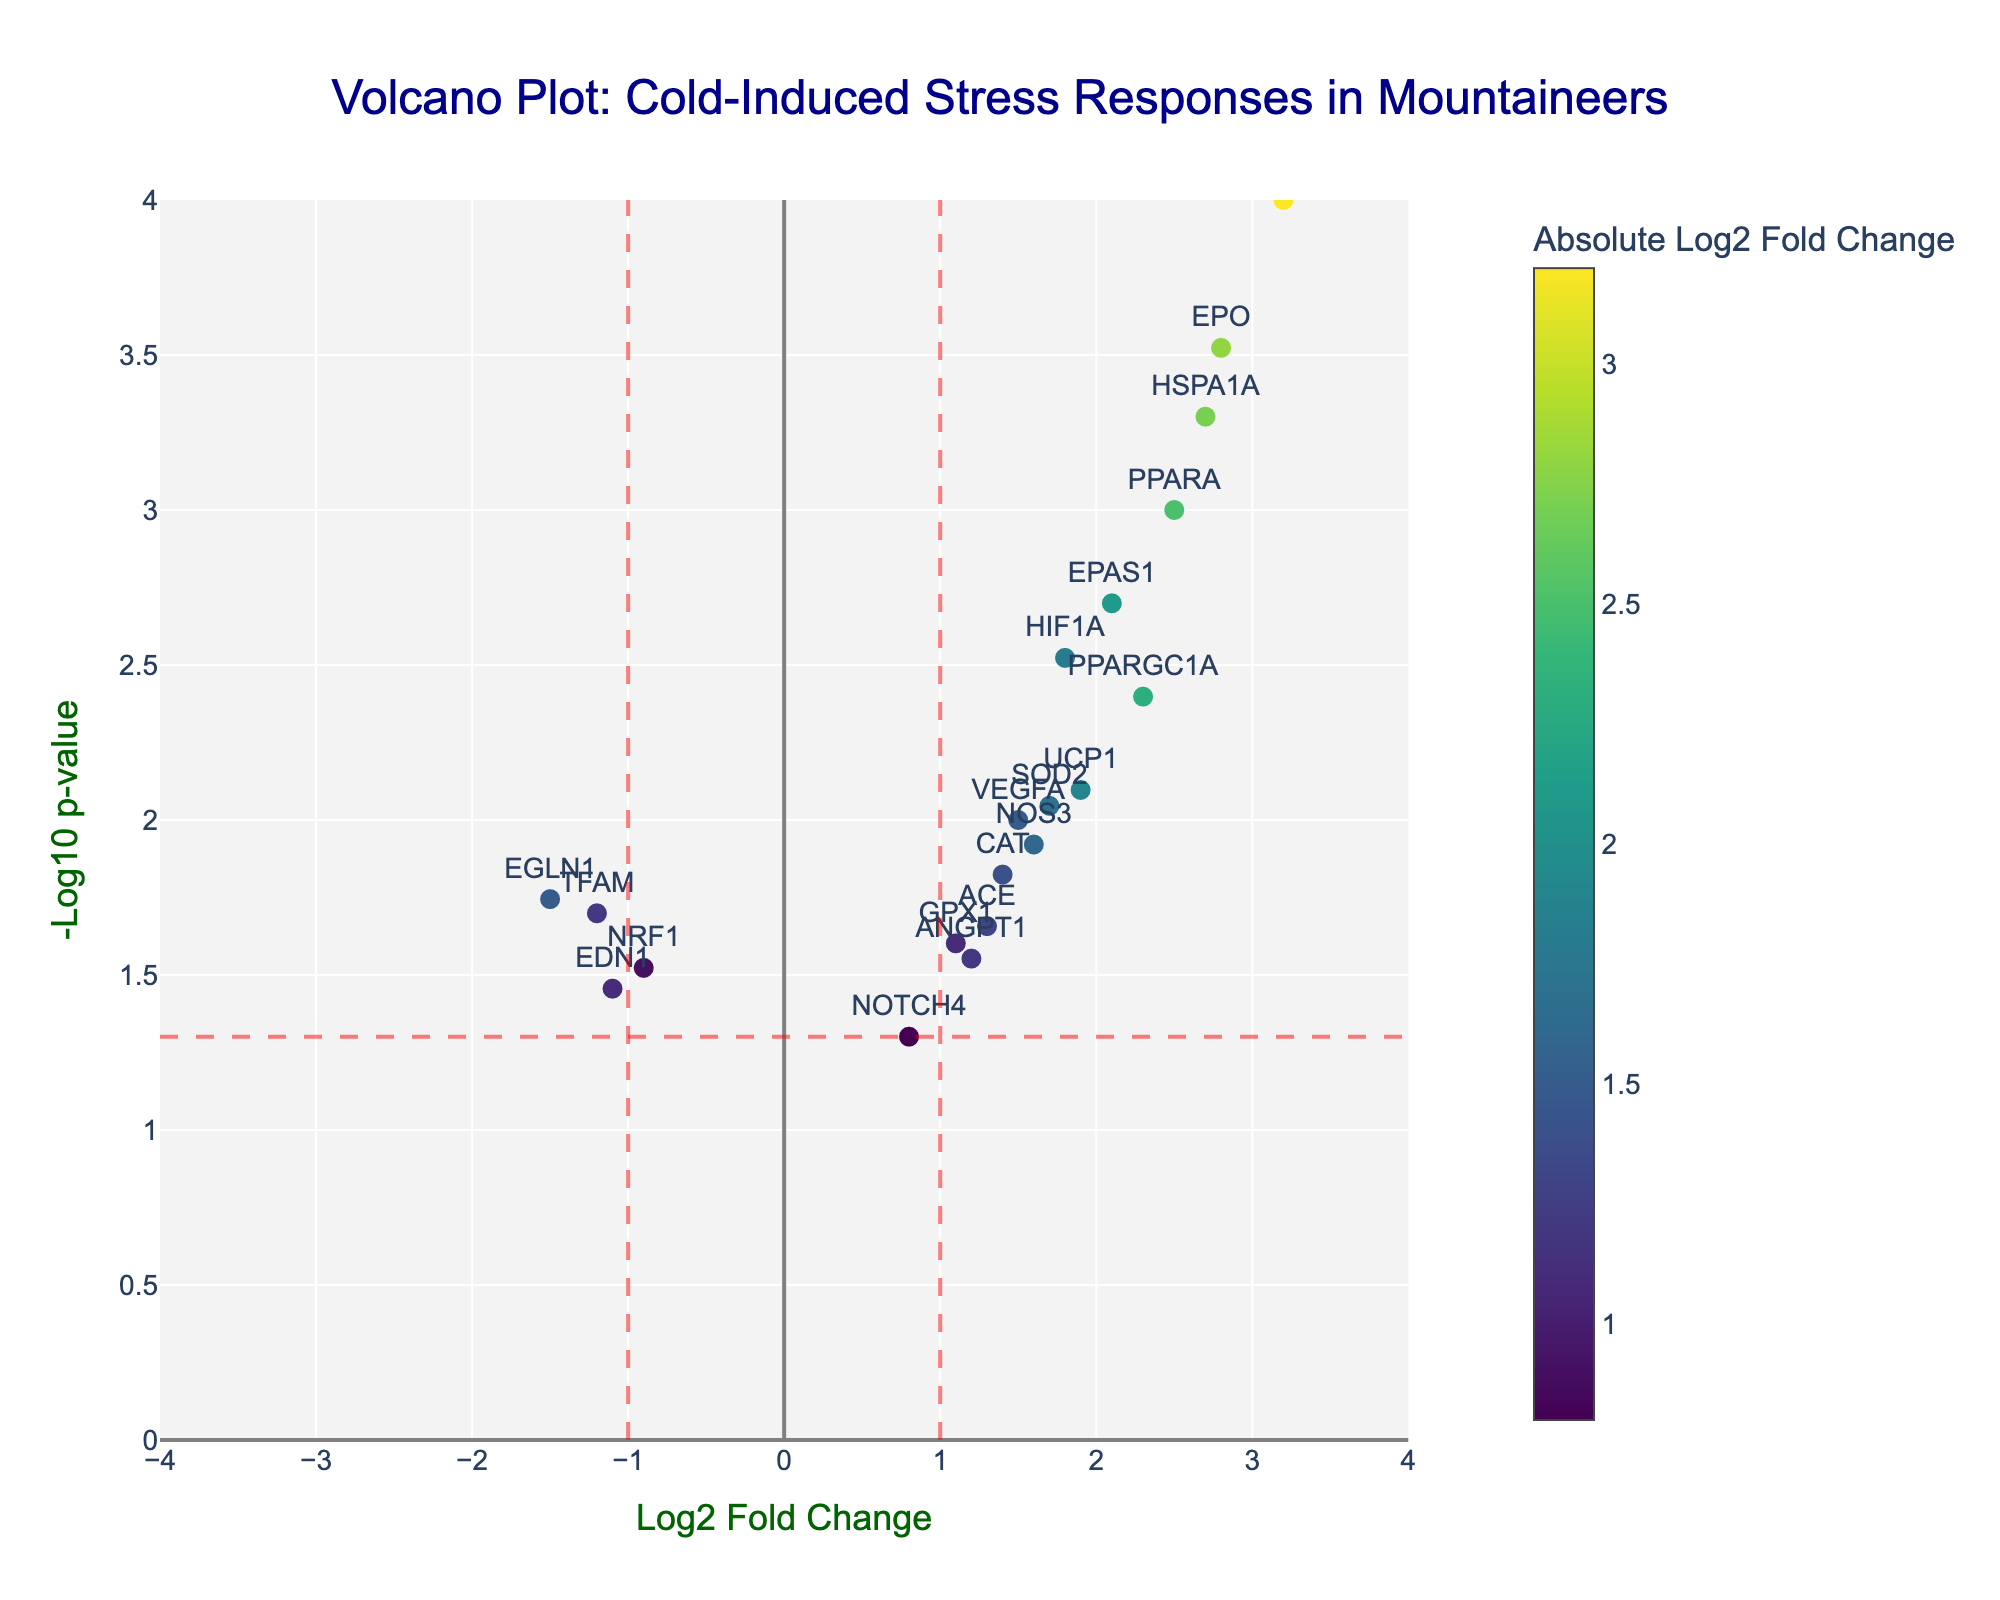What is the title of the volcano plot? The title of the plot is usually at the top of the figure and provides an overview of what the plot represents. In this case, the title is "Volcano Plot: Cold-Induced Stress Responses in Mountaineers."
Answer: Volcano Plot: Cold-Induced Stress Responses in Mountaineers What do the x and y axes represent? The x-axis represents the log2 fold change of the gene expression, indicating how much the expression of a gene changes, while the y-axis represents the -log10 of the p-value, which indicates the statistical significance of these changes.
Answer: x-axis: Log2 Fold Change; y-axis: -Log10 p-value Which gene has the highest log2 fold change? By looking at the x-axis, we can identify that HSP90AA1, which is placed at around 3.2 on the x-axis, has the highest log2 fold change.
Answer: HSP90AA1 Which gene has the lowest p-value? The y-axis represents the -log10 p-value, so the gene with the highest position on the y-axis has the lowest p-value. HSP90AA1 at the top of the plot on the y-axis represents the gene with the lowest p-value.
Answer: HSP90AA1 How many genes have a p-value less than 0.01? A p-value less than 0.01 corresponds to a -log10 p-value greater than 2. We look for data points above the y = 2 line. The genes are PPARA, HIF1A, EPAS1, HSP90AA1, HSPA1A, PPARGC1A, and EPO, resulting in 7 genes.
Answer: 7 Which genes are downregulated and statistically significant? Downregulated genes have negative log2 fold changes, and statistically significant genes have p-values less than 0.05 (-log10 p-value > 1.3). The genes are TFAM, EGLN1, and EDN1.
Answer: TFAM, EGLN1, EDN1 How many genes show a log2 fold change greater than 2? We identify genes with log2 fold changes greater than 2 by counting the points on the right side of the x = 2 line. These genes are PPARA, EPAS1, HSP90AA1, HSPA1A, and EPO, giving us 5 genes.
Answer: 5 Which gene has a log2 fold change close to zero but is statistically significant? A gene with a log2 fold change close to zero and statistically significant will be near the center of the x-axis and high on the y-axis. NOTCH4 has a log2 fold change of 0.8 and a p-value of 0.05, making it the closest match.
Answer: NOTCH4 Which gene has the second lowest p-value? The gene with the second-highest position on the y-axis has the second lowest p-value. EPO is the second-highest, hence it has the second lowest p-value.
Answer: EPO 